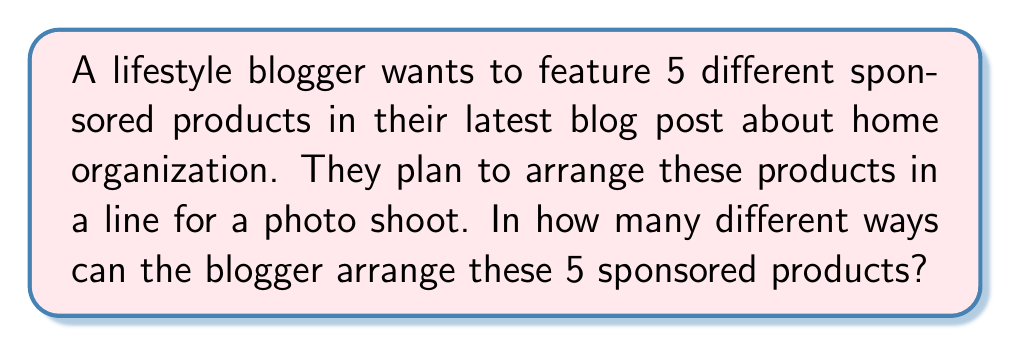Can you solve this math problem? To solve this problem, we need to use the concept of permutations. Here's a step-by-step explanation:

1) We have 5 distinct sponsored products that need to be arranged in a line.

2) This is a straightforward permutation problem because:
   - The order matters (different arrangements result in different photos)
   - All items are being used (all 5 products will be in the photo)
   - Each item can only be used once (we don't have duplicate products)

3) The formula for permutations of n distinct objects is:

   $$P(n) = n!$$

   Where $n!$ represents the factorial of $n$.

4) In this case, $n = 5$, so we need to calculate $5!$:

   $$5! = 5 \times 4 \times 3 \times 2 \times 1 = 120$$

5) Therefore, there are 120 different ways to arrange the 5 sponsored products.

This result means the lifestyle blogger has 120 unique options for arranging the products in their photo shoot, allowing for a variety of visual presentations in their blog post.
Answer: $120$ 